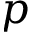Convert formula to latex. <formula><loc_0><loc_0><loc_500><loc_500>p</formula> 